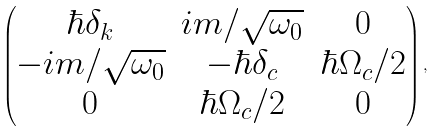<formula> <loc_0><loc_0><loc_500><loc_500>\begin{pmatrix} \hbar { \delta } _ { k } & i m / \sqrt { \omega _ { 0 } } & 0 \\ - i m / \sqrt { \omega _ { 0 } } & - \hbar { \delta } _ { c } & \hbar { \Omega } _ { c } / 2 \\ 0 & \hbar { \Omega } _ { c } / 2 & 0 \end{pmatrix} ,</formula> 